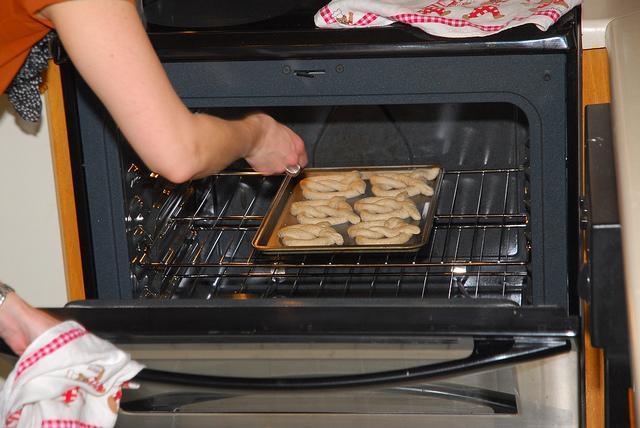How many oven racks are there?
Give a very brief answer. 2. How many stories does this bus have?
Give a very brief answer. 0. 